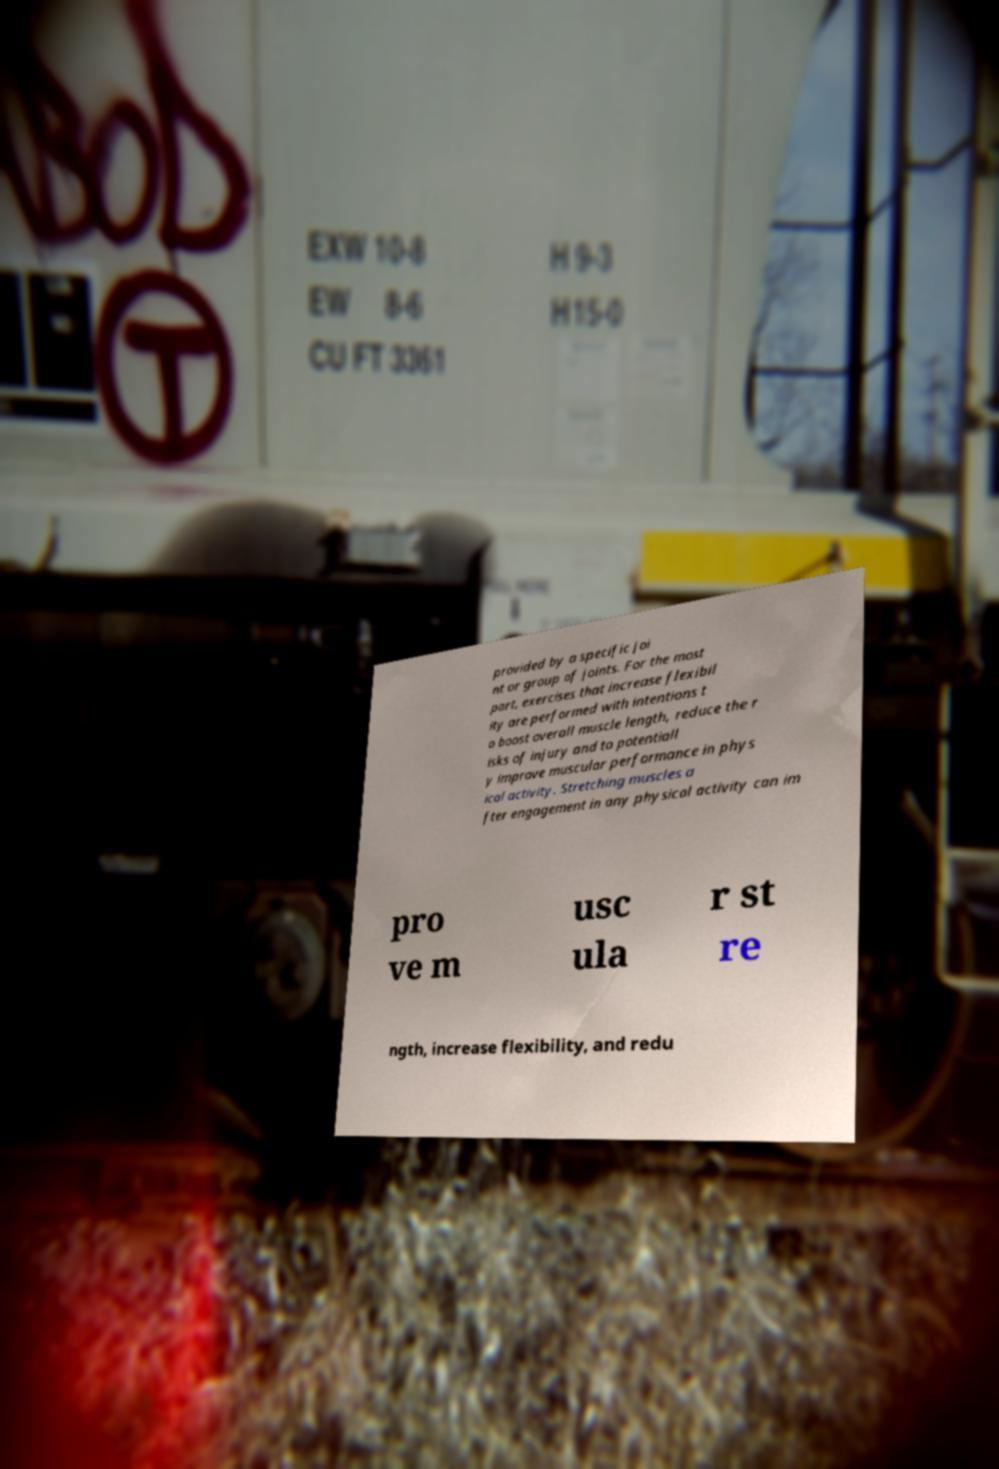I need the written content from this picture converted into text. Can you do that? provided by a specific joi nt or group of joints. For the most part, exercises that increase flexibil ity are performed with intentions t o boost overall muscle length, reduce the r isks of injury and to potentiall y improve muscular performance in phys ical activity. Stretching muscles a fter engagement in any physical activity can im pro ve m usc ula r st re ngth, increase flexibility, and redu 